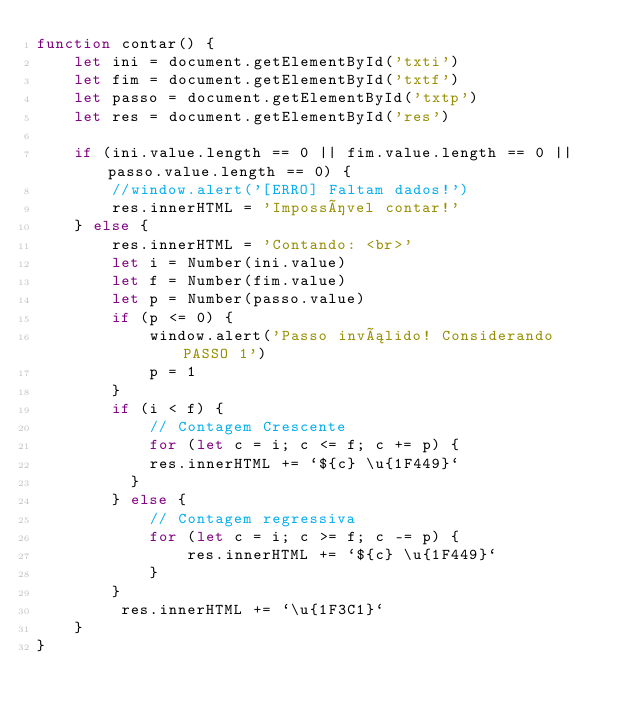<code> <loc_0><loc_0><loc_500><loc_500><_JavaScript_>function contar() {
    let ini = document.getElementById('txti')
    let fim = document.getElementById('txtf')
    let passo = document.getElementById('txtp')
    let res = document.getElementById('res')

    if (ini.value.length == 0 || fim.value.length == 0 || passo.value.length == 0) {
        //window.alert('[ERRO] Faltam dados!')
        res.innerHTML = 'Impossível contar!'
    } else {
        res.innerHTML = 'Contando: <br>'
        let i = Number(ini.value)
        let f = Number(fim.value)
        let p = Number(passo.value)
        if (p <= 0) {
            window.alert('Passo inválido! Considerando PASSO 1')
            p = 1
        }
        if (i < f) {
            // Contagem Crescente
            for (let c = i; c <= f; c += p) {
            res.innerHTML += `${c} \u{1F449}`
          }
        } else {
            // Contagem regressiva
            for (let c = i; c >= f; c -= p) {
                res.innerHTML += `${c} \u{1F449}`
            } 
        }
         res.innerHTML += `\u{1F3C1}`
    }
}</code> 